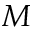<formula> <loc_0><loc_0><loc_500><loc_500>M</formula> 